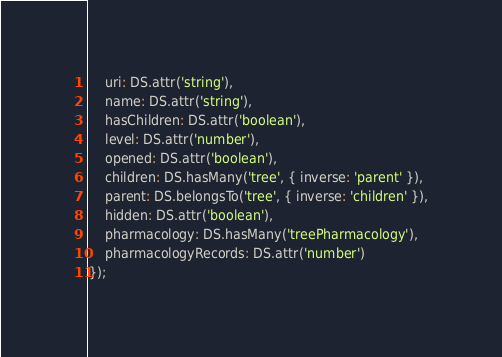Convert code to text. <code><loc_0><loc_0><loc_500><loc_500><_JavaScript_>    uri: DS.attr('string'),
    name: DS.attr('string'),
    hasChildren: DS.attr('boolean'),
    level: DS.attr('number'),
    opened: DS.attr('boolean'),
    children: DS.hasMany('tree', { inverse: 'parent' }),
    parent: DS.belongsTo('tree', { inverse: 'children' }),
    hidden: DS.attr('boolean'),
    pharmacology: DS.hasMany('treePharmacology'),
    pharmacologyRecords: DS.attr('number')
});
</code> 